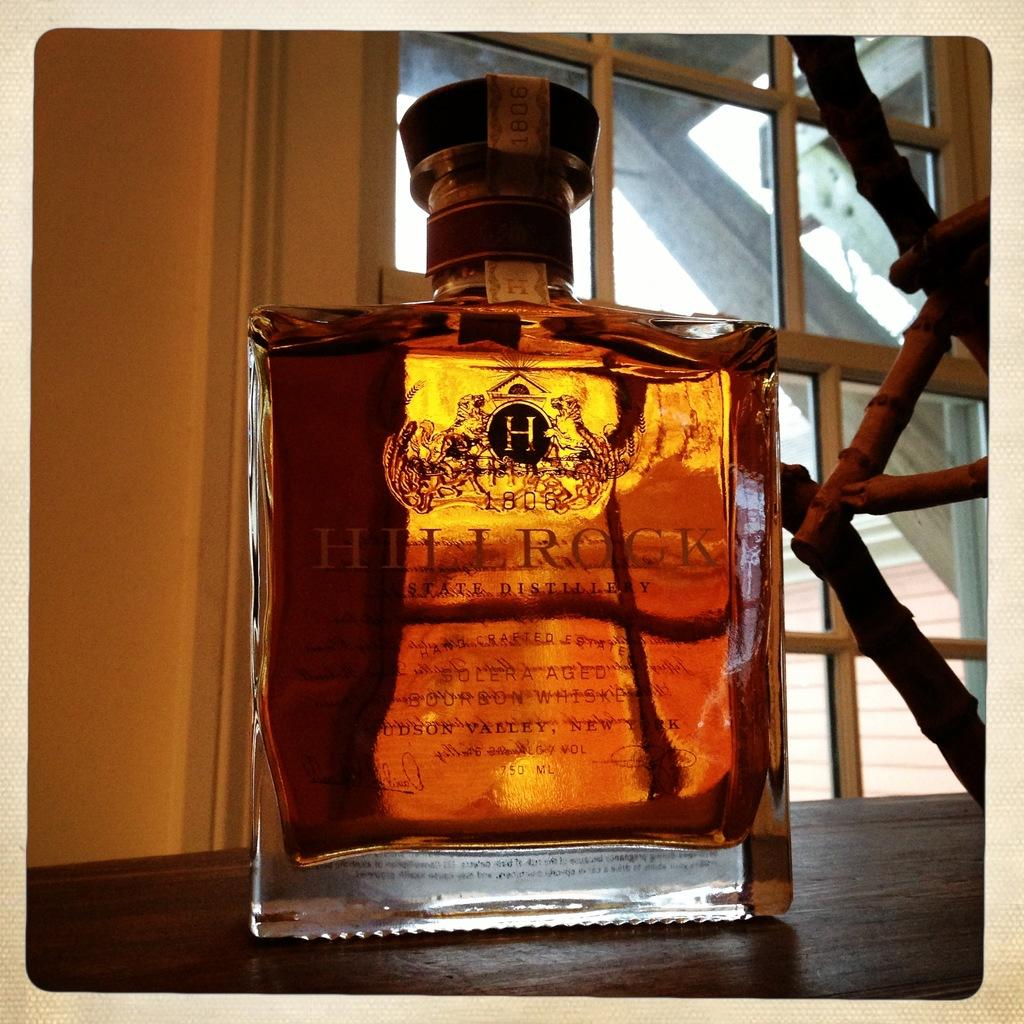Provide a one-sentence caption for the provided image. A light brown liquor with the name Hill Rock printed on it. 